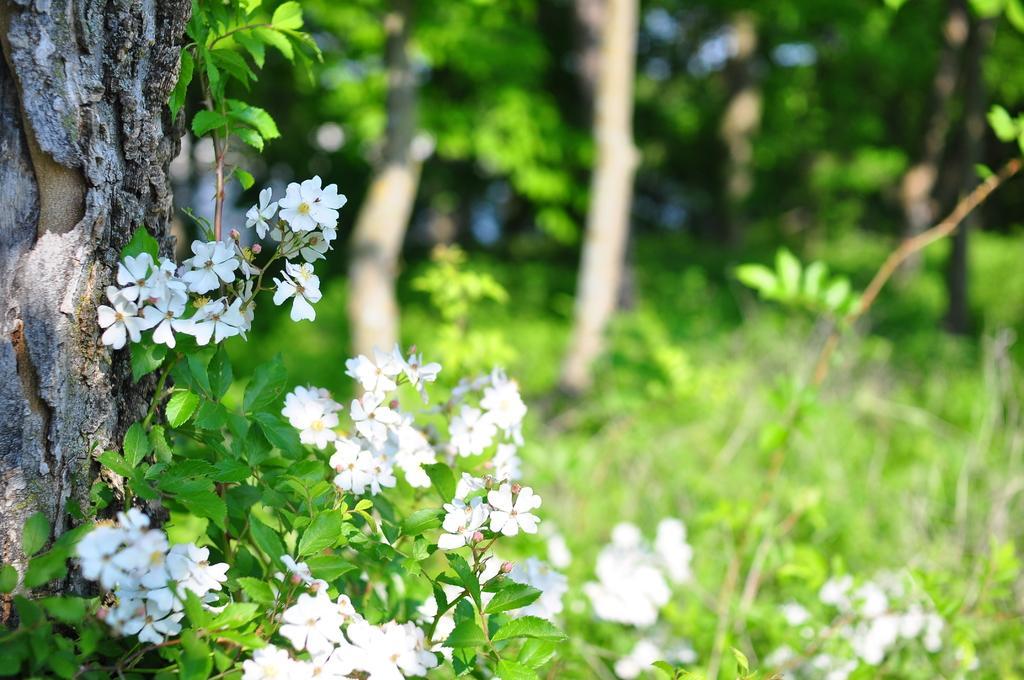Can you describe this image briefly? In this picture I can see plants, flowers, and in the background there are trees. 